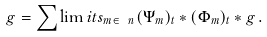Convert formula to latex. <formula><loc_0><loc_0><loc_500><loc_500>g = \sum \lim i t s _ { m \in \ n } ( \Psi _ { m } ) _ { t } \ast ( \Phi _ { m } ) _ { t } \ast g \, .</formula> 